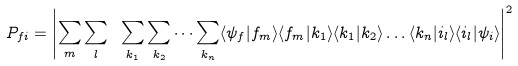Convert formula to latex. <formula><loc_0><loc_0><loc_500><loc_500>P _ { f i } = \left | \sum _ { m } \sum _ { l } \ \sum _ { k _ { 1 } } \sum _ { k _ { 2 } } \dots \sum _ { k _ { n } } \langle \psi _ { f } | f _ { m } \rangle \langle f _ { m } | k _ { 1 } \rangle \langle k _ { 1 } | k _ { 2 } \rangle \dots \langle k _ { n } | i _ { l } \rangle \langle i _ { l } | \psi _ { i } \rangle \right | ^ { 2 }</formula> 